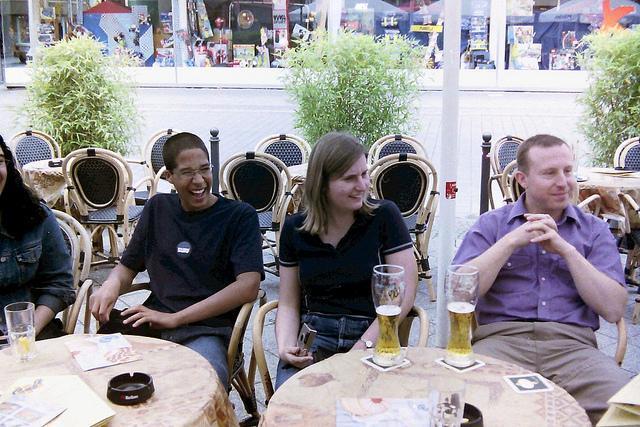How many people is being fully shown in this picture?
Give a very brief answer. 3. How many people are seated at the table?
Give a very brief answer. 4. How many women?
Give a very brief answer. 2. How many people can you see?
Give a very brief answer. 4. How many potted plants are there?
Give a very brief answer. 3. How many chairs are there?
Give a very brief answer. 5. How many cups are in the picture?
Give a very brief answer. 2. How many dining tables can you see?
Give a very brief answer. 2. 